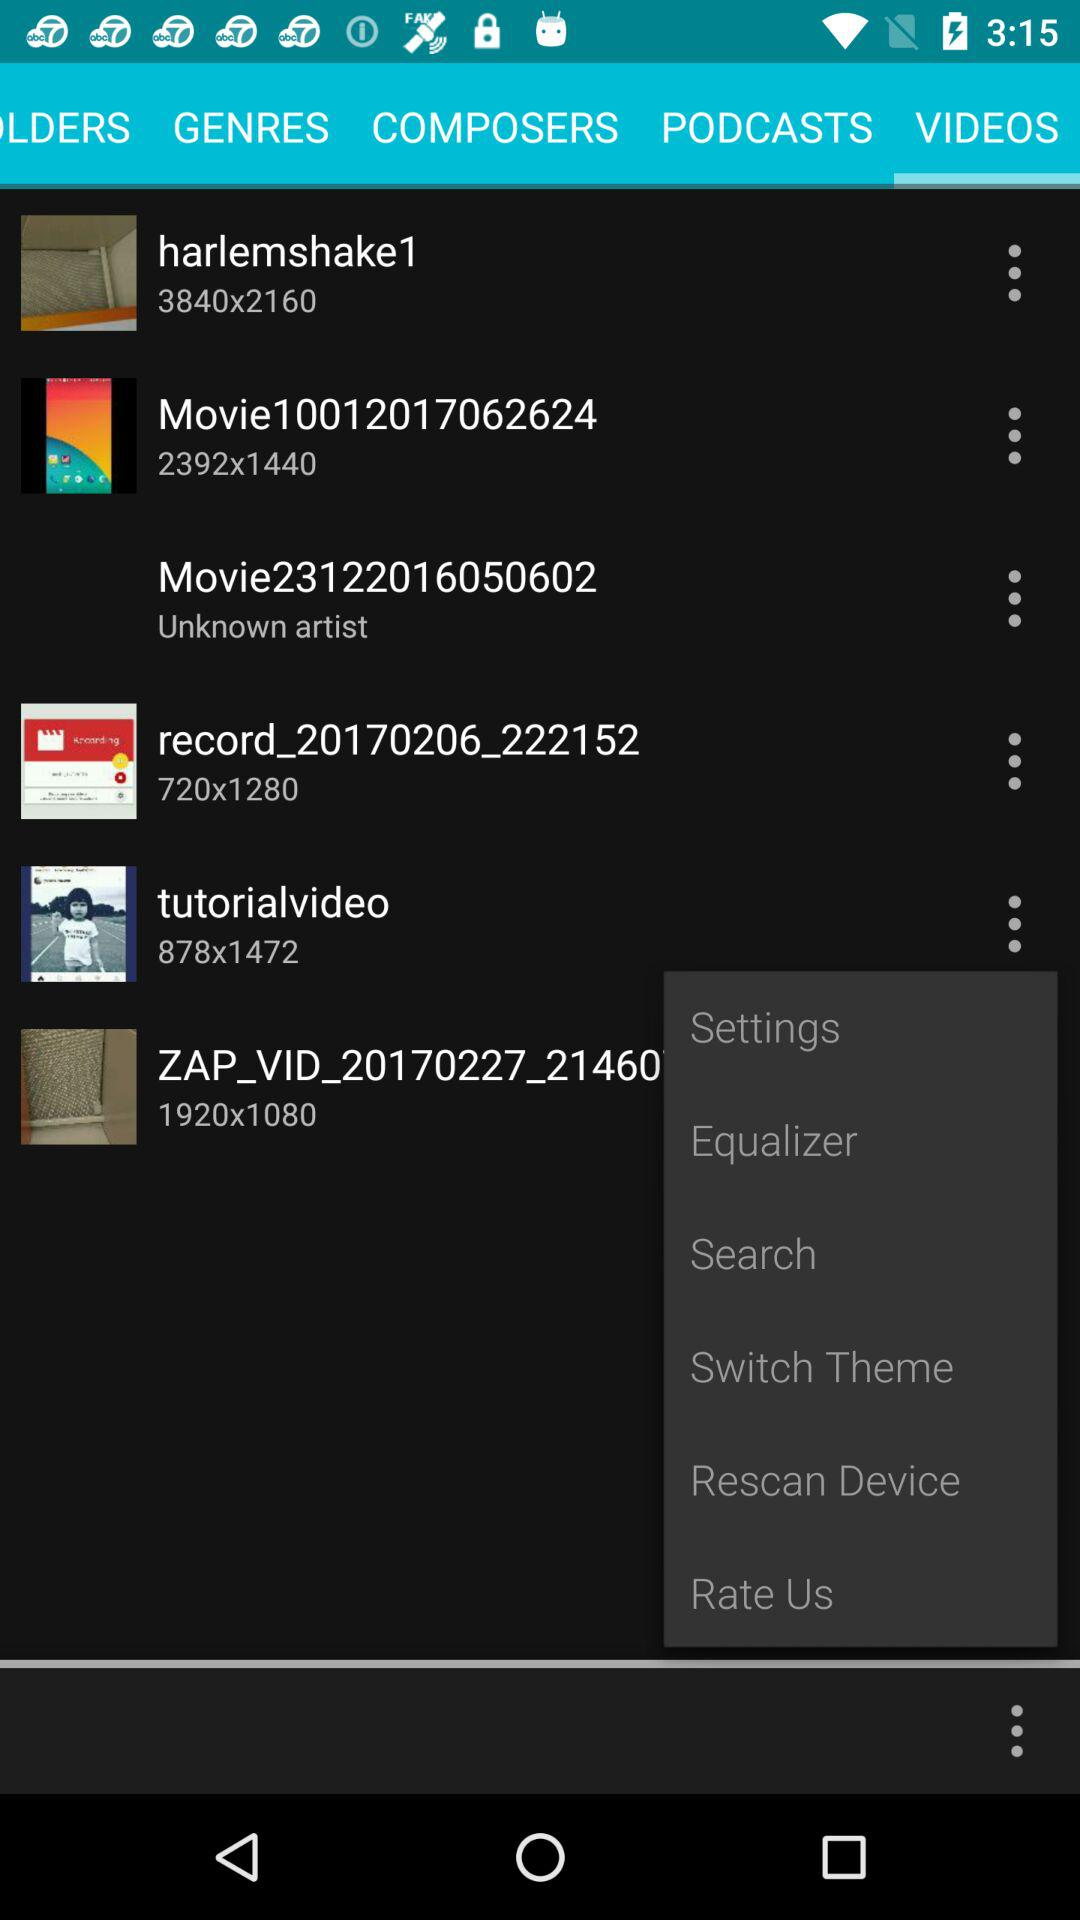Which tab has been selected? The tab that has been selected is "VIDEOS". 